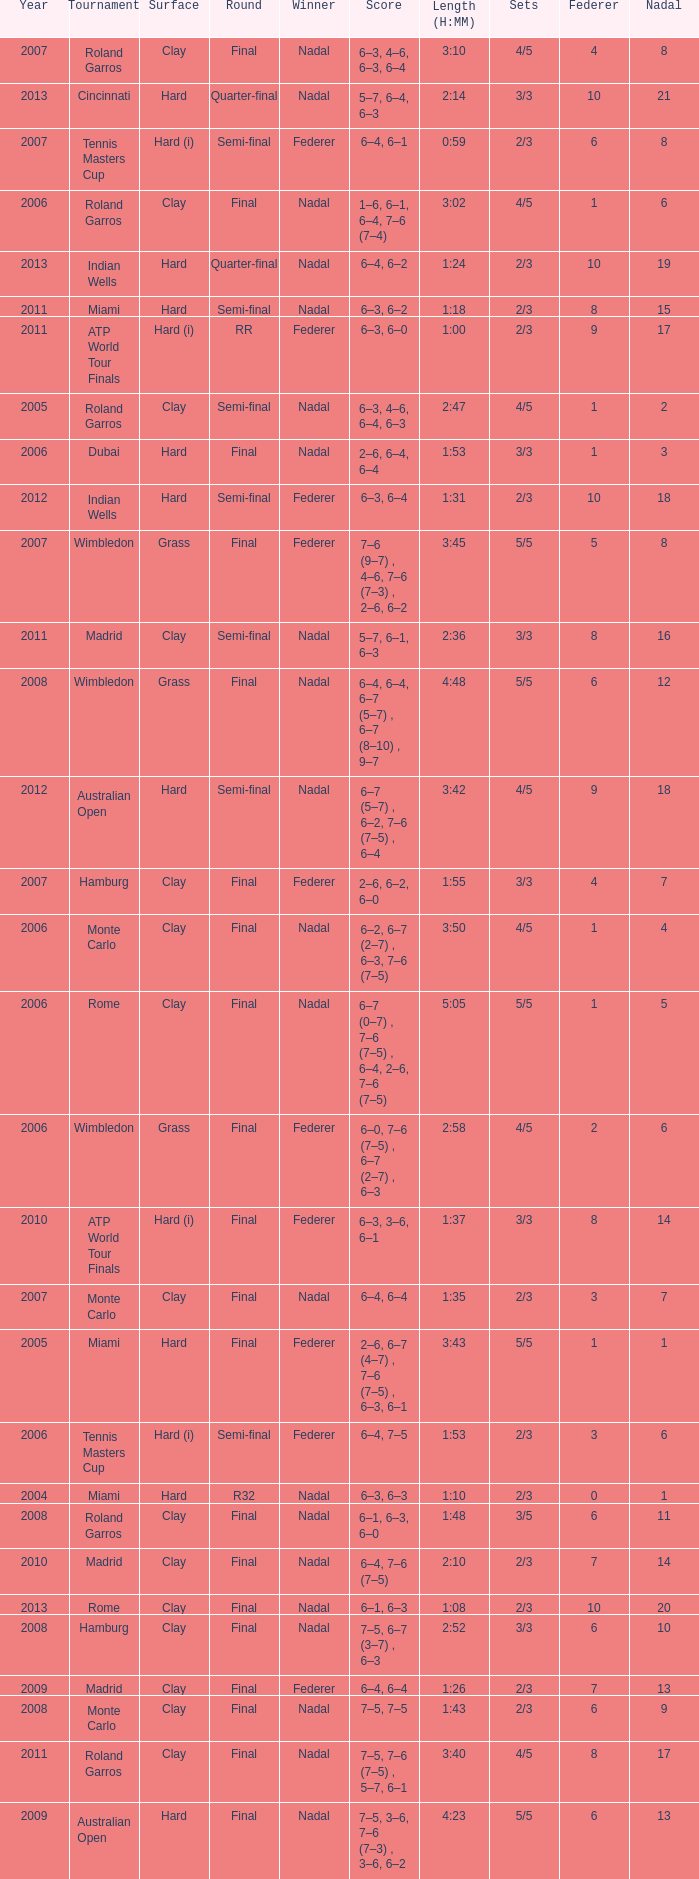What was the nadal in Miami in the final round? 1.0. 